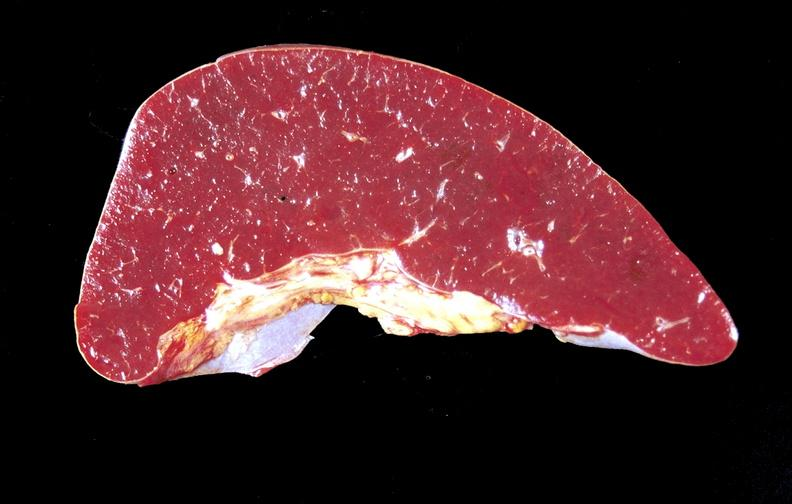s hematologic present?
Answer the question using a single word or phrase. Yes 